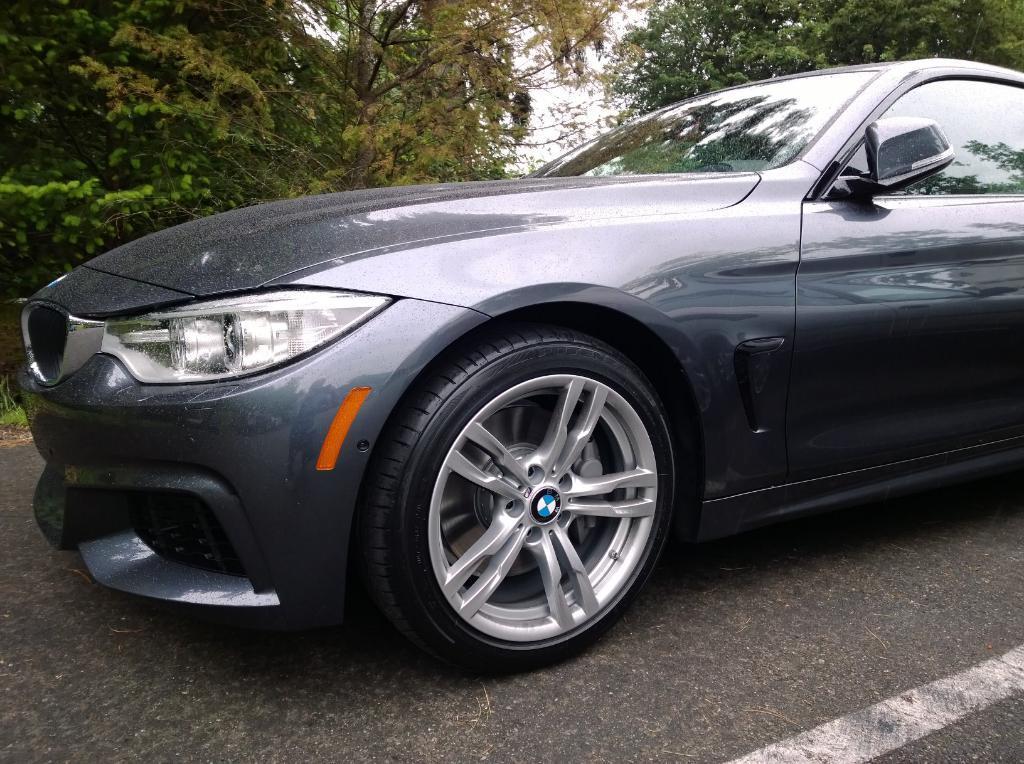In one or two sentences, can you explain what this image depicts? In this image I can see a car on the road. It is in grey color, at the top there are trees. 